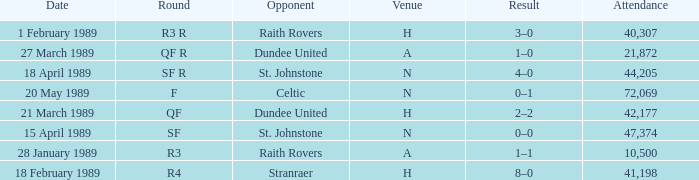What is the date when the round is sf? 15 April 1989. 